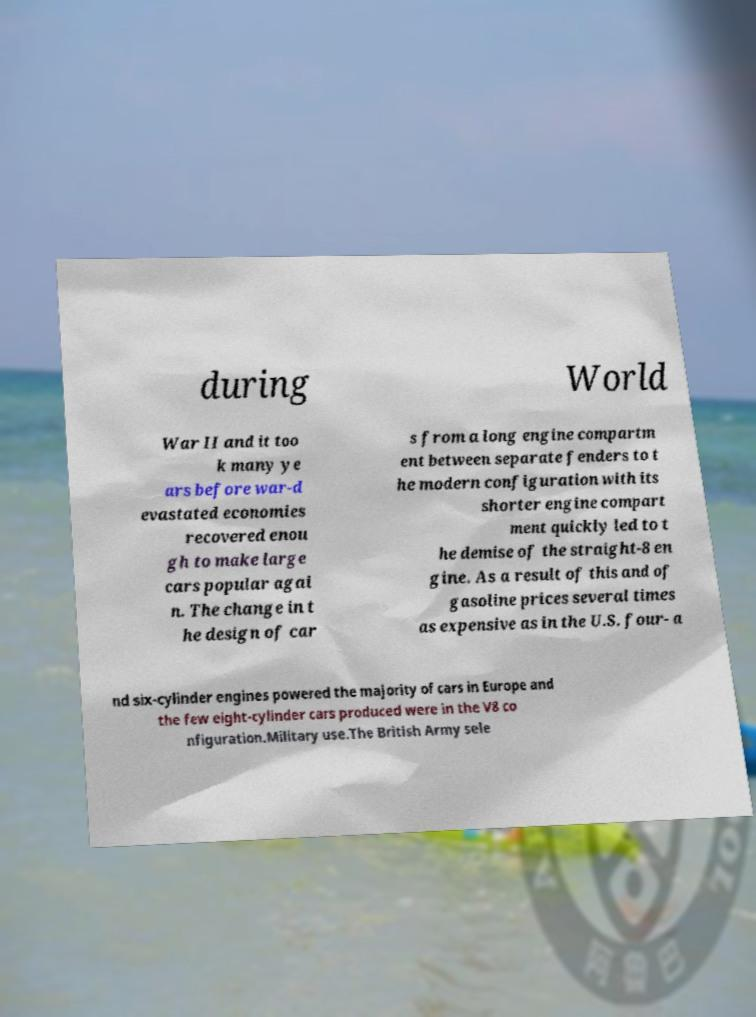What messages or text are displayed in this image? I need them in a readable, typed format. during World War II and it too k many ye ars before war-d evastated economies recovered enou gh to make large cars popular agai n. The change in t he design of car s from a long engine compartm ent between separate fenders to t he modern configuration with its shorter engine compart ment quickly led to t he demise of the straight-8 en gine. As a result of this and of gasoline prices several times as expensive as in the U.S. four- a nd six-cylinder engines powered the majority of cars in Europe and the few eight-cylinder cars produced were in the V8 co nfiguration.Military use.The British Army sele 